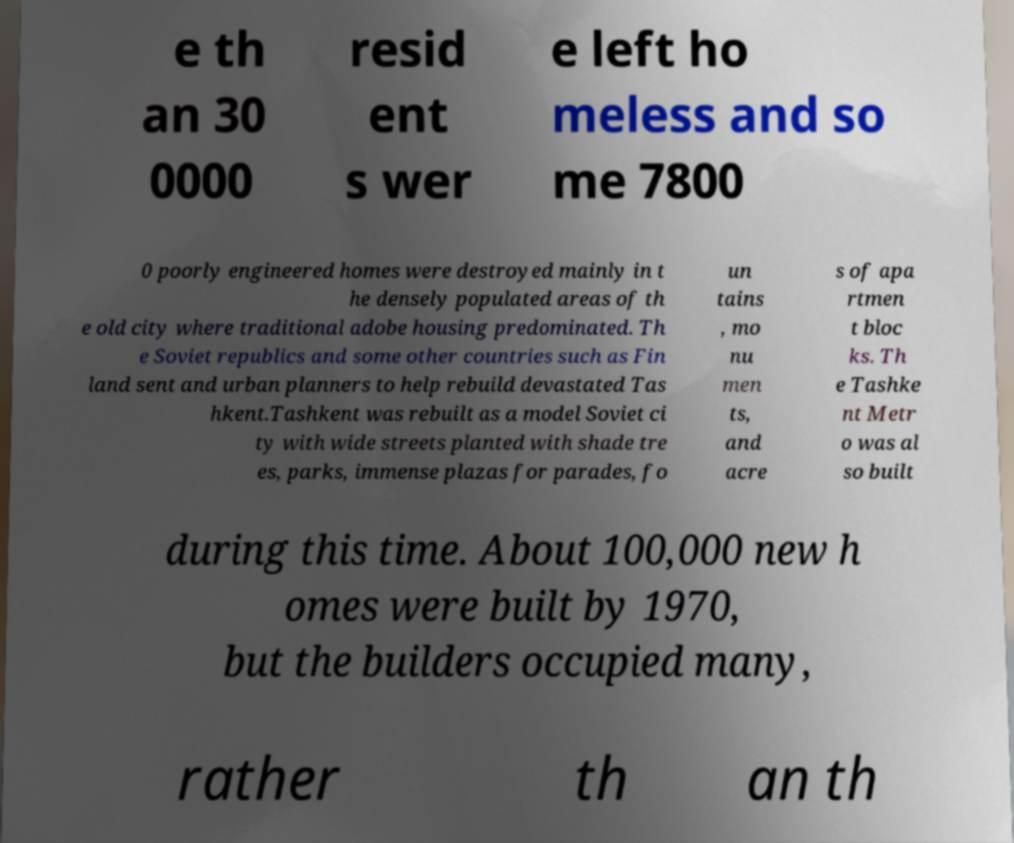Can you accurately transcribe the text from the provided image for me? e th an 30 0000 resid ent s wer e left ho meless and so me 7800 0 poorly engineered homes were destroyed mainly in t he densely populated areas of th e old city where traditional adobe housing predominated. Th e Soviet republics and some other countries such as Fin land sent and urban planners to help rebuild devastated Tas hkent.Tashkent was rebuilt as a model Soviet ci ty with wide streets planted with shade tre es, parks, immense plazas for parades, fo un tains , mo nu men ts, and acre s of apa rtmen t bloc ks. Th e Tashke nt Metr o was al so built during this time. About 100,000 new h omes were built by 1970, but the builders occupied many, rather th an th 